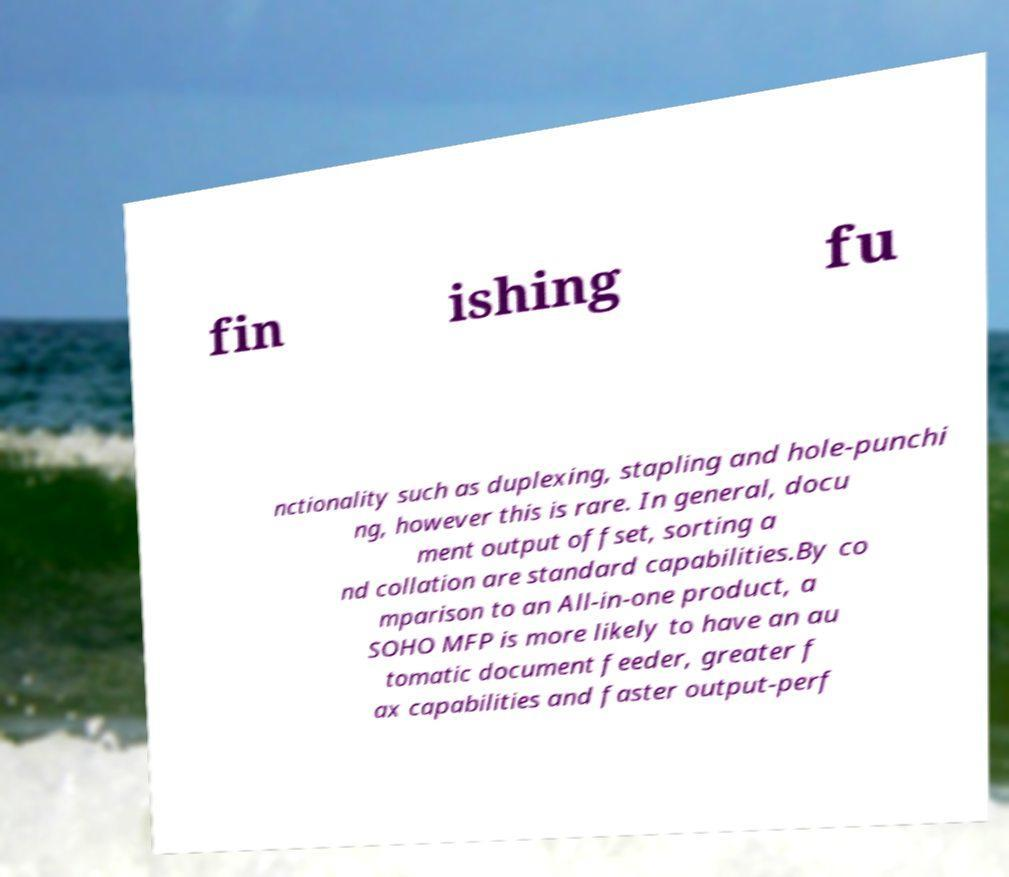Could you assist in decoding the text presented in this image and type it out clearly? fin ishing fu nctionality such as duplexing, stapling and hole-punchi ng, however this is rare. In general, docu ment output offset, sorting a nd collation are standard capabilities.By co mparison to an All-in-one product, a SOHO MFP is more likely to have an au tomatic document feeder, greater f ax capabilities and faster output-perf 